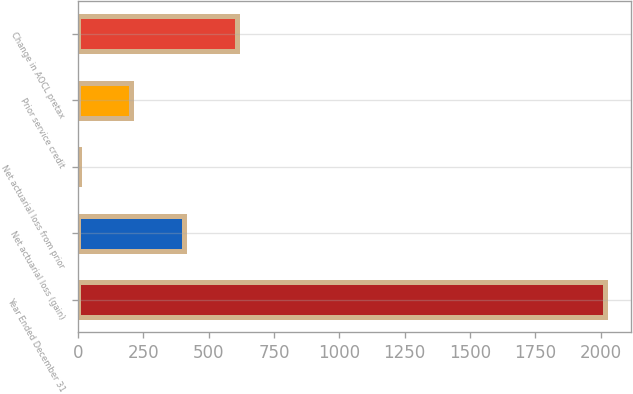Convert chart to OTSL. <chart><loc_0><loc_0><loc_500><loc_500><bar_chart><fcel>Year Ended December 31<fcel>Net actuarial loss (gain)<fcel>Net actuarial loss from prior<fcel>Prior service credit<fcel>Change in AOCL pretax<nl><fcel>2016<fcel>405.6<fcel>3<fcel>204.3<fcel>606.9<nl></chart> 